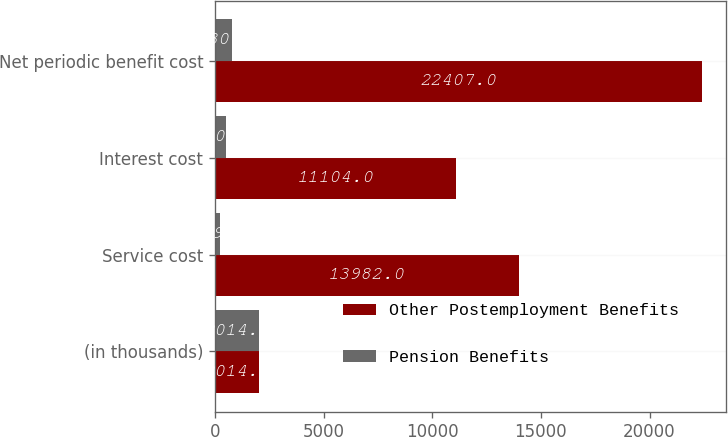<chart> <loc_0><loc_0><loc_500><loc_500><stacked_bar_chart><ecel><fcel>(in thousands)<fcel>Service cost<fcel>Interest cost<fcel>Net periodic benefit cost<nl><fcel>Other Postemployment Benefits<fcel>2014<fcel>13982<fcel>11104<fcel>22407<nl><fcel>Pension Benefits<fcel>2014<fcel>249<fcel>530<fcel>780<nl></chart> 